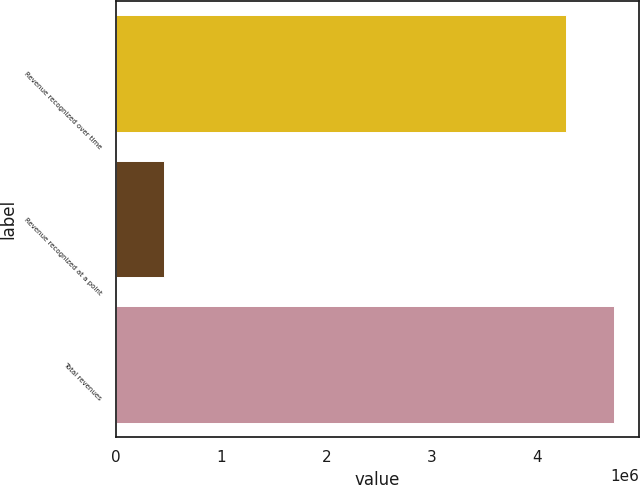Convert chart. <chart><loc_0><loc_0><loc_500><loc_500><bar_chart><fcel>Revenue recognized over time<fcel>Revenue recognized at a point<fcel>Total revenues<nl><fcel>4.27193e+06<fcel>458332<fcel>4.73027e+06<nl></chart> 